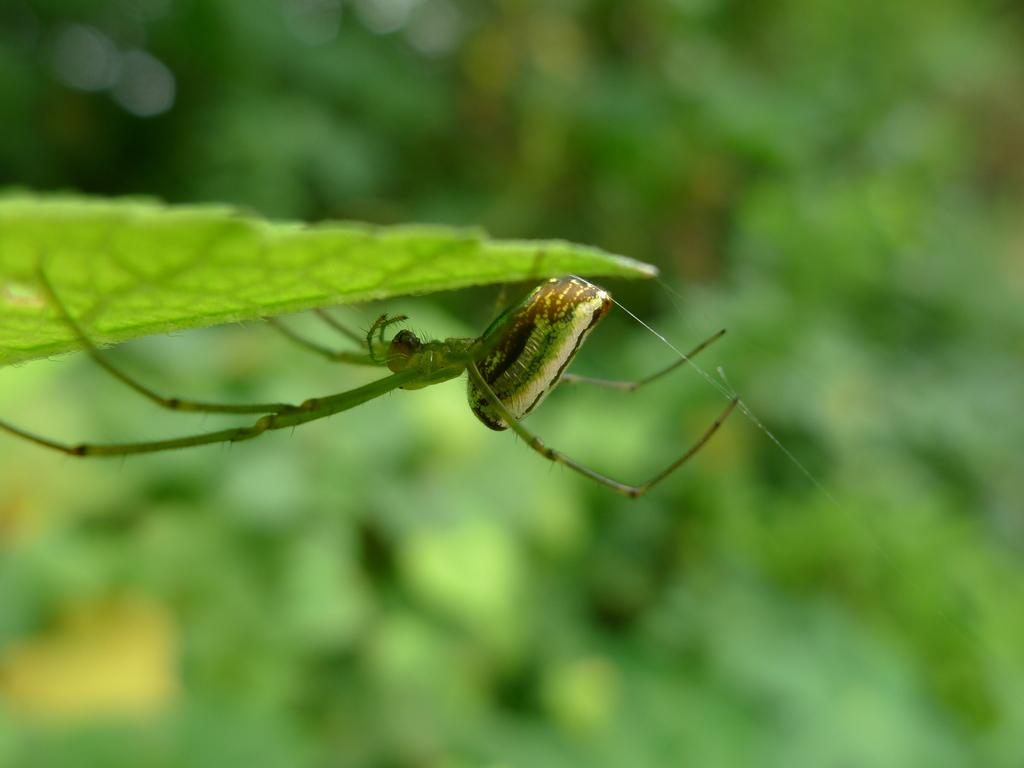What is present in the image? There is an insect in the image. Where is the insect located? The insect is under a leaf. Can you describe the background of the image? The background of the image is blurry. How many stomachs does the giant horse have in the image? There is no giant horse present in the image, so it is not possible to determine the number of stomachs it might have. 